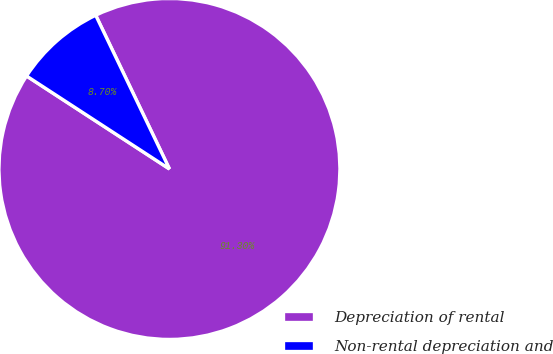Convert chart to OTSL. <chart><loc_0><loc_0><loc_500><loc_500><pie_chart><fcel>Depreciation of rental<fcel>Non-rental depreciation and<nl><fcel>91.3%<fcel>8.7%<nl></chart> 